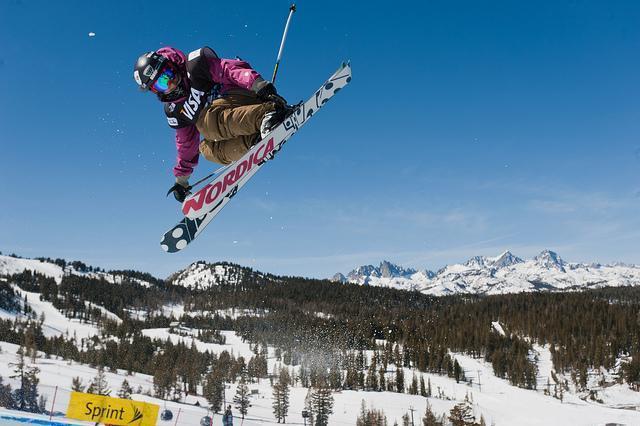How many cars of the train can you fully see?
Give a very brief answer. 0. 